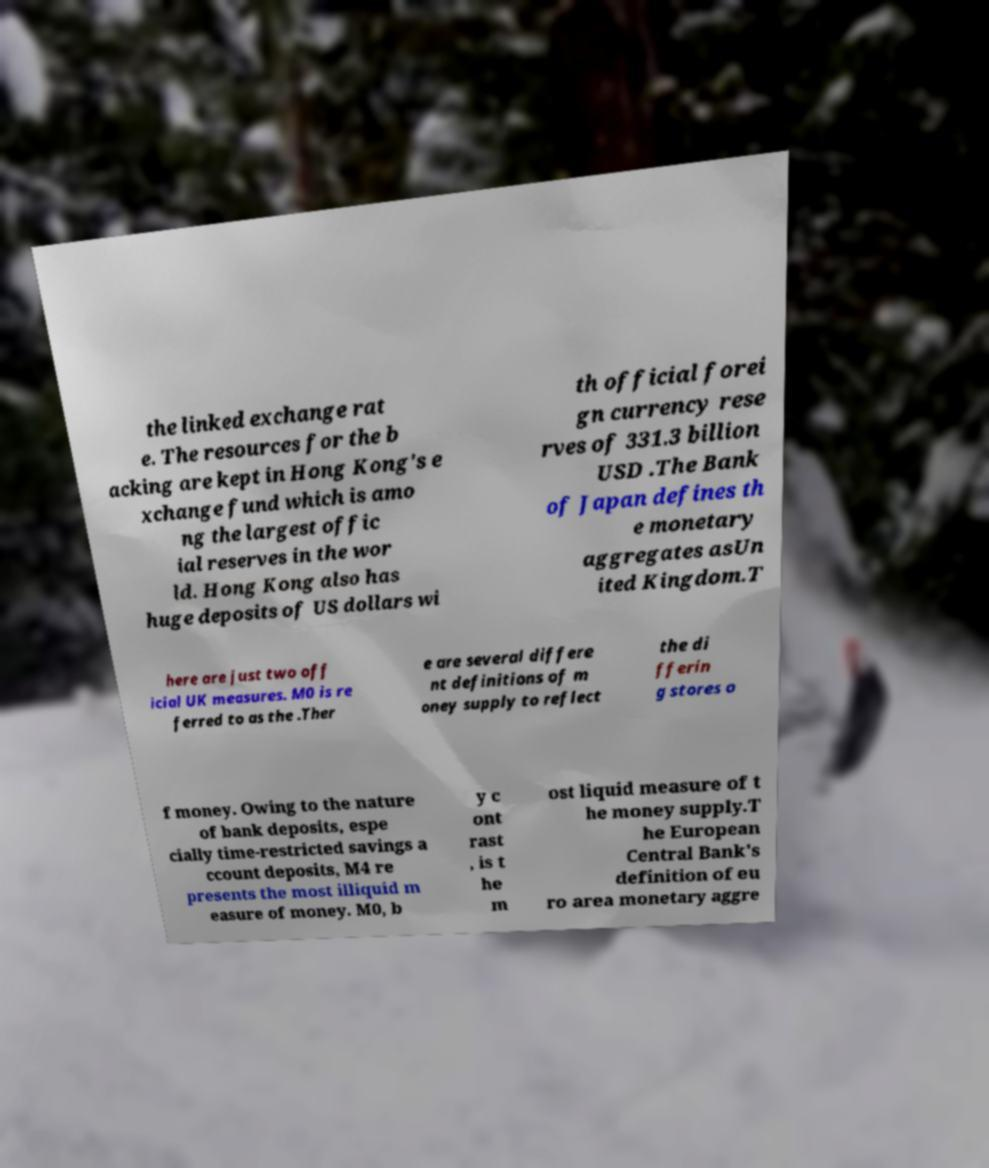What messages or text are displayed in this image? I need them in a readable, typed format. the linked exchange rat e. The resources for the b acking are kept in Hong Kong's e xchange fund which is amo ng the largest offic ial reserves in the wor ld. Hong Kong also has huge deposits of US dollars wi th official forei gn currency rese rves of 331.3 billion USD .The Bank of Japan defines th e monetary aggregates asUn ited Kingdom.T here are just two off icial UK measures. M0 is re ferred to as the .Ther e are several differe nt definitions of m oney supply to reflect the di fferin g stores o f money. Owing to the nature of bank deposits, espe cially time-restricted savings a ccount deposits, M4 re presents the most illiquid m easure of money. M0, b y c ont rast , is t he m ost liquid measure of t he money supply.T he European Central Bank's definition of eu ro area monetary aggre 